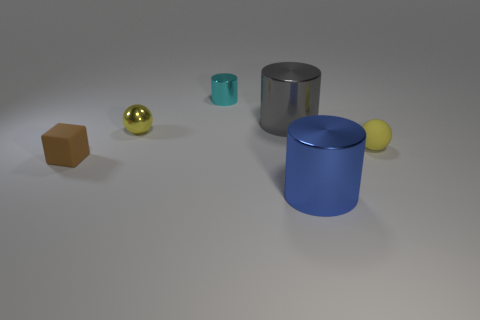Are there more tiny brown blocks that are in front of the yellow metallic ball than green matte balls?
Provide a succinct answer. Yes. There is a object that is both in front of the small rubber sphere and right of the tiny brown block; what size is it?
Your response must be concise. Large. What is the shape of the object that is both in front of the yellow rubber object and to the left of the tiny cyan metallic thing?
Your response must be concise. Cube. There is a rubber object right of the large metal thing behind the small brown object; are there any yellow matte objects in front of it?
Ensure brevity in your answer.  No. How many objects are either small objects right of the matte block or matte things on the left side of the big gray thing?
Provide a succinct answer. 4. Does the big object that is in front of the small brown rubber thing have the same material as the tiny cyan object?
Ensure brevity in your answer.  Yes. What material is the thing that is both in front of the small yellow matte sphere and on the right side of the block?
Provide a succinct answer. Metal. What color is the big object in front of the tiny brown rubber thing on the left side of the gray shiny cylinder?
Provide a succinct answer. Blue. There is another yellow object that is the same shape as the yellow shiny object; what is it made of?
Make the answer very short. Rubber. There is a large cylinder that is in front of the yellow thing that is in front of the tiny ball behind the small rubber sphere; what is its color?
Your answer should be compact. Blue. 